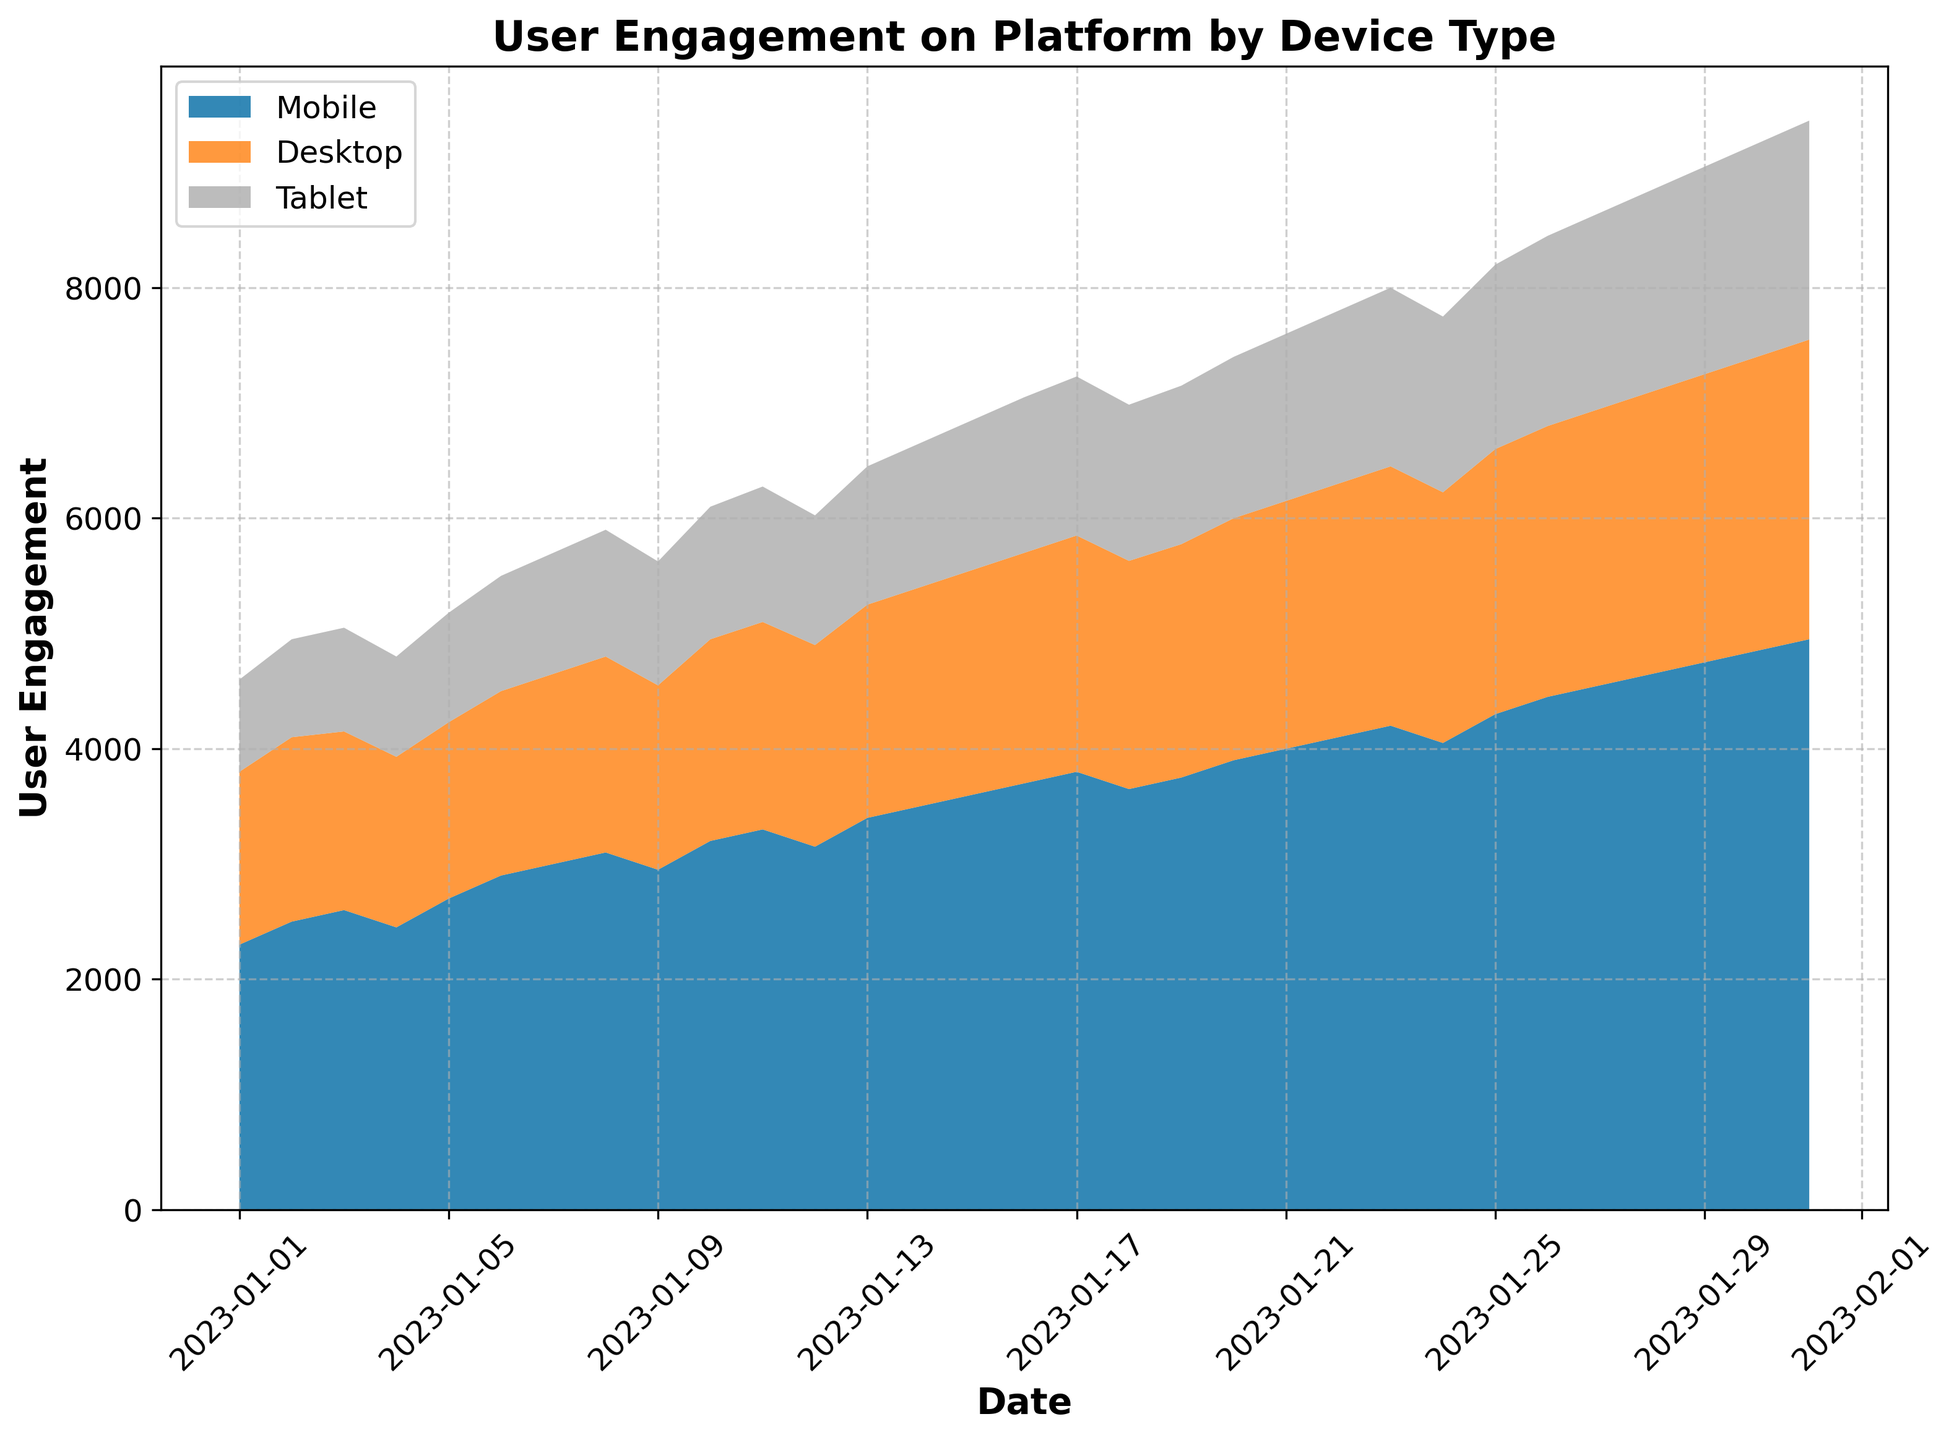What's the trend for user engagement on Mobile devices over the month? Observing the area chart, the user engagement on Mobile devices shows a generally increasing trend throughout the month. Starting from 2300 on January 1st, the engagement steadily rises to 4950 by January 31st. This reflects a growth in user activity on Mobile devices over the period.
Answer: Increasing trend Which day had the highest total user engagement on the platform? By examining the total height of the stacked areas on the chart, the maximum total user engagement occurs on January 31st, accounting for Mobile, Desktop, and Tablet users.
Answer: January 31st Can you compare the user engagement between Desktop and Tablet devices on January 20th? Look at the stacked areas for January 20th. The Desktop engagement is represented in a smaller area below the Tablet’s area. Desktop has 2100 while Tablet has 1400, meaning Desktop engagement is higher.
Answer: Desktop What is the total user engagement on January 15th? Sum the user engagements for all devices on January 15th. Mobile: 3600, Desktop: 1950, Tablet: 1300. The total is 3600 + 1950 + 1300 = 6850.
Answer: 6850 How does the user engagement on January 10th compare to January 1st for Tablet devices? Check the height of the Tablet part of the stacked area on both dates. January 1st has 800 and January 10th has 1150. The difference is 1150 - 800 = 350. So, January 10th has 350 more engagements.
Answer: 350 more on January 10th Which device type shows the most consistent (least variable) user engagement over the month? Determine by comparing the smoothness and variation of the stacked areas for each device. The Desktop device shows the most consistent engagement with a relatively smooth and less variable trendline from 1500 at the start to 2600 at the end.
Answer: Desktop What’s the average user engagement for Mobile devices from January 1st to January 7th? Calculate the sum of Mobile engagements during the first week and divide by 7. Sum: 2300 + 2500 + 2600 + 2450 + 2700 + 2900 + 3000 = 18450. Average: 18450/7 ≈ 2636.
Answer: 2636 Compare the growth rate in user engagement on Mobile between the first and last week. First week increase: 3000 - 2300 = 700. Last week increase: 4950 - 4000 = 950. Mobile engagement grew by 700 in the first week and by 950 in the last week.
Answer: Higher growth in the last week How does Desktop engagement on January 15th visually compare to January 25th? Compare the height of the Desktop sections on these dates. January 15th's height is less than January 25th's height. Numbers: 1950 on 15th and 2300 on 25th. So, January 25th has more engagement.
Answer: Higher on January 25th 